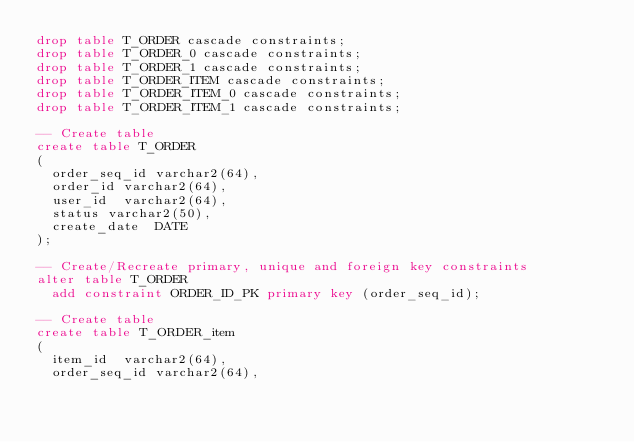<code> <loc_0><loc_0><loc_500><loc_500><_SQL_>drop table T_ORDER cascade constraints;
drop table T_ORDER_0 cascade constraints;
drop table T_ORDER_1 cascade constraints;
drop table T_ORDER_ITEM cascade constraints;
drop table T_ORDER_ITEM_0 cascade constraints;
drop table T_ORDER_ITEM_1 cascade constraints;

-- Create table
create table T_ORDER
(
  order_seq_id varchar2(64),
  order_id varchar2(64),
  user_id  varchar2(64),
  status varchar2(50),
  create_date  DATE
);

-- Create/Recreate primary, unique and foreign key constraints 
alter table T_ORDER
  add constraint ORDER_ID_PK primary key (order_seq_id);
  
-- Create table
create table T_ORDER_item
(
  item_id  varchar2(64),
  order_seq_id varchar2(64),</code> 